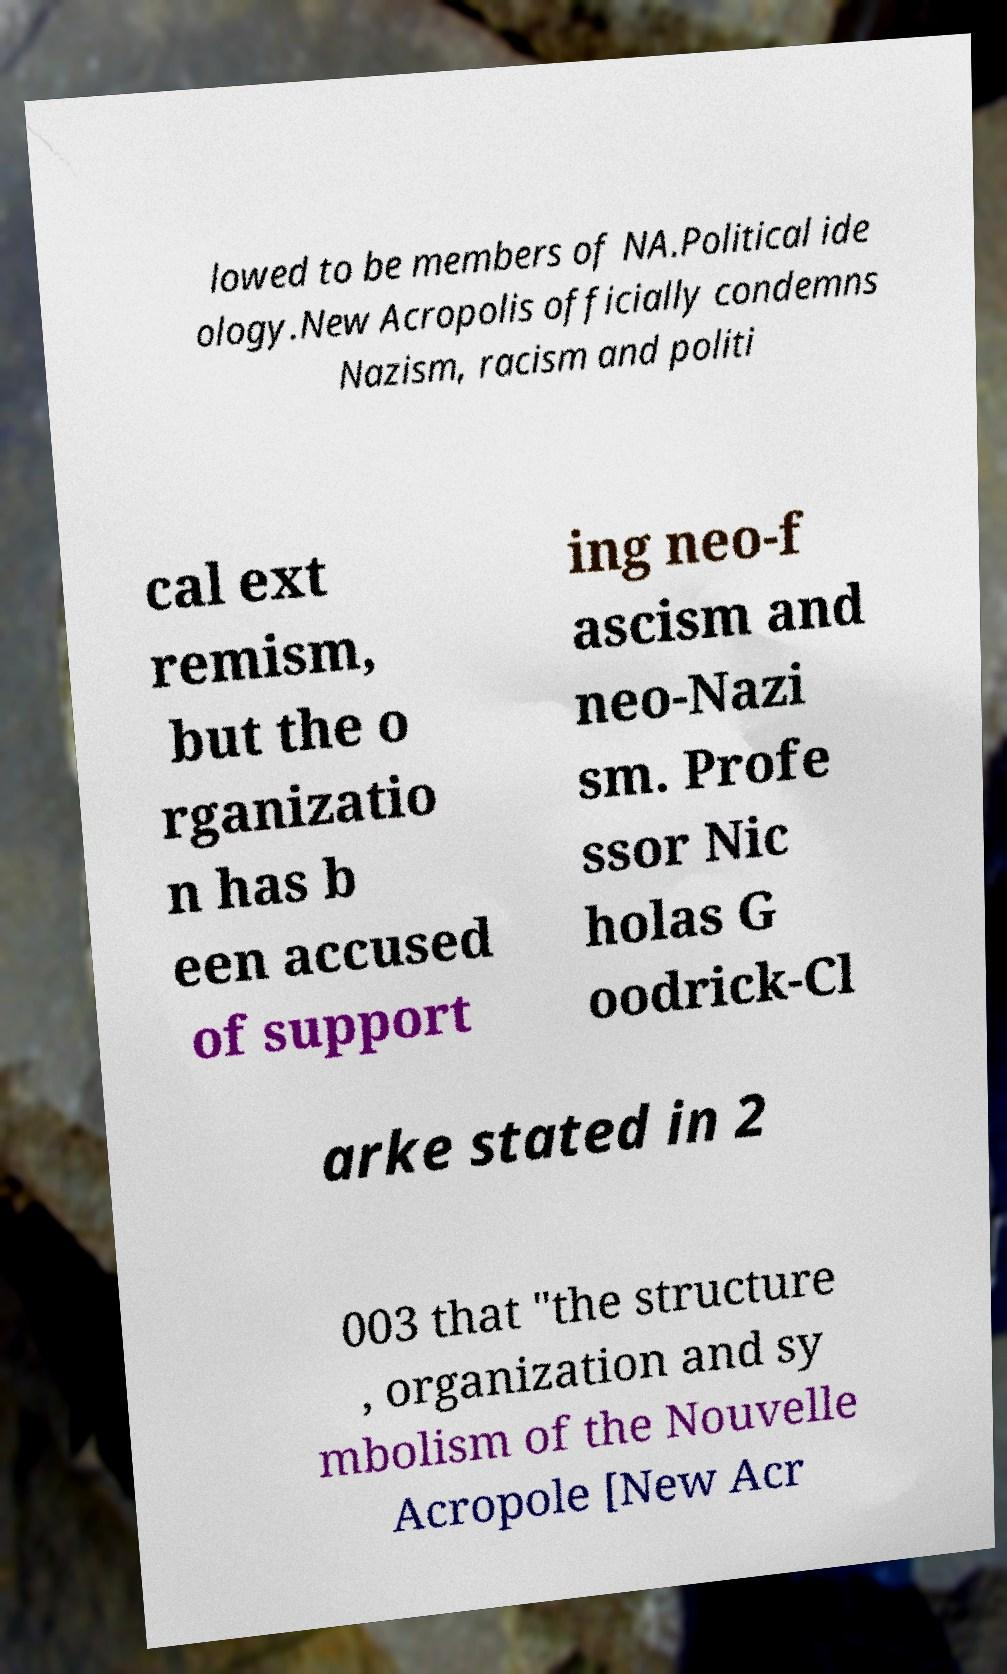Could you assist in decoding the text presented in this image and type it out clearly? lowed to be members of NA.Political ide ology.New Acropolis officially condemns Nazism, racism and politi cal ext remism, but the o rganizatio n has b een accused of support ing neo-f ascism and neo-Nazi sm. Profe ssor Nic holas G oodrick-Cl arke stated in 2 003 that "the structure , organization and sy mbolism of the Nouvelle Acropole [New Acr 